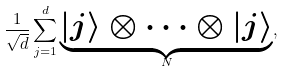<formula> <loc_0><loc_0><loc_500><loc_500>\frac { 1 } { \sqrt { d } } \sum _ { j = 1 } ^ { d } \underset { N } { \underbrace { | j \rangle \otimes \cdots \otimes | j \rangle } } ,</formula> 